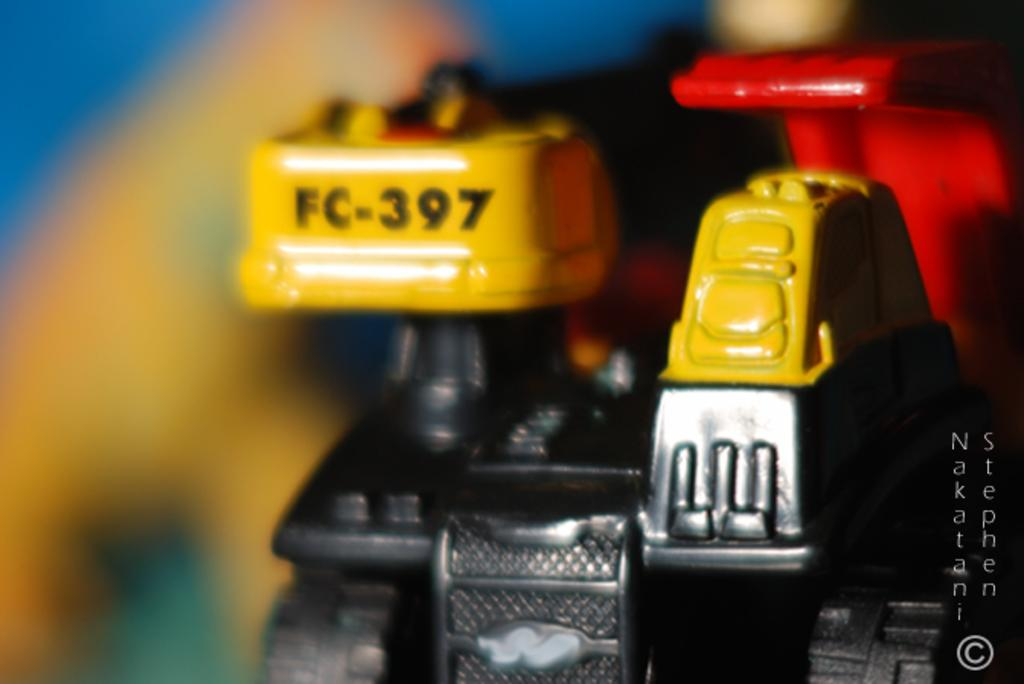Provide a one-sentence caption for the provided image. A piece of equipment numbered FC-397 on the top of the yellow piece. 